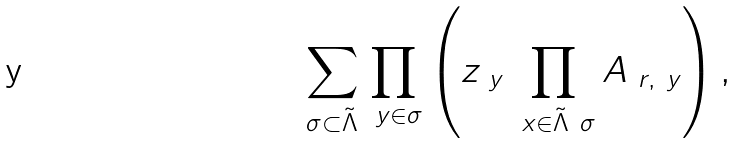<formula> <loc_0><loc_0><loc_500><loc_500>\sum _ { \sigma \subset \tilde { \Lambda } } \prod _ { \ y \in \sigma } \left ( z _ { \ y } \prod _ { \ x \in \tilde { \Lambda } \ \sigma } A _ { \ r , \ y } \right ) ,</formula> 